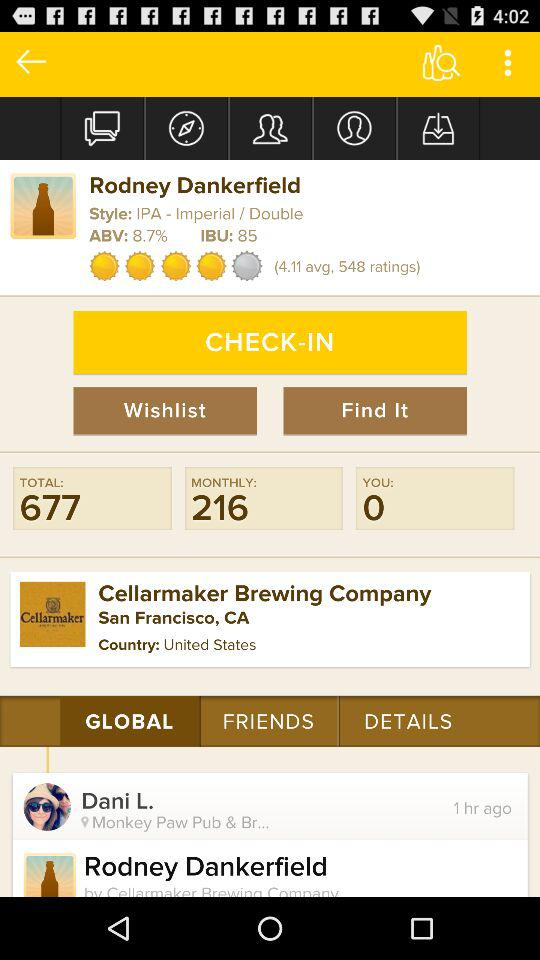Who was available one hour ago? The user Dani L. was available one hour ago. 